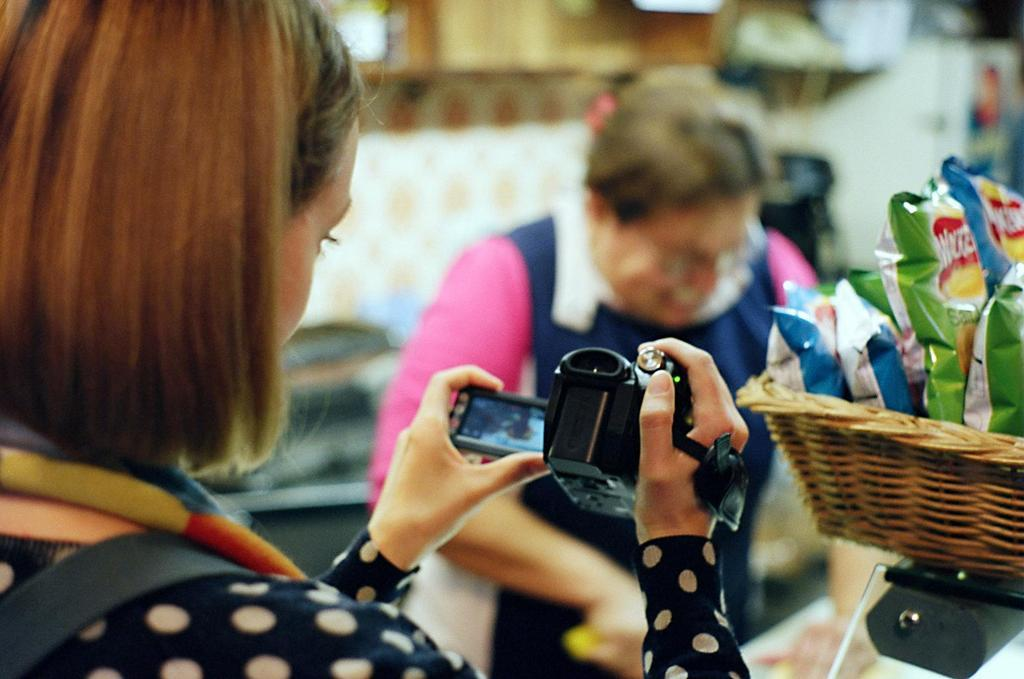Who is the main subject in the image? There is a lady in the image. What is the lady holding in the image? The lady is holding a camera. What can be seen on the right side of the image? There is a basket with packets on the right side of the image. Can you describe the background of the image? The background appears blurry, and there is another person in the background. What type of comb is the lady using to fold the bottle in the image? There is no comb or bottle present in the image. 